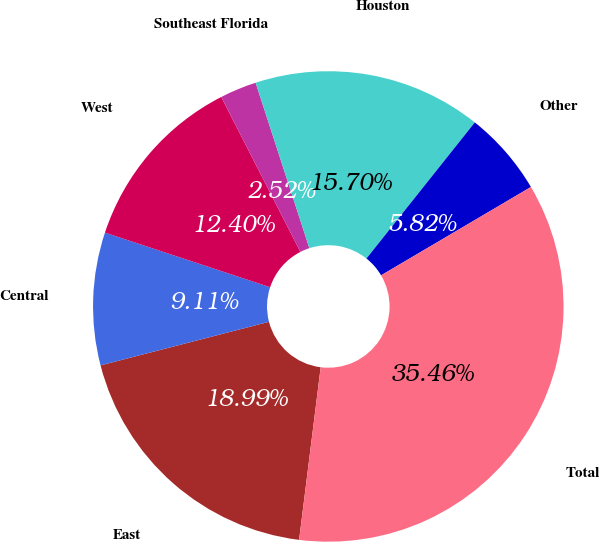Convert chart. <chart><loc_0><loc_0><loc_500><loc_500><pie_chart><fcel>East<fcel>Central<fcel>West<fcel>Southeast Florida<fcel>Houston<fcel>Other<fcel>Total<nl><fcel>18.99%<fcel>9.11%<fcel>12.4%<fcel>2.52%<fcel>15.7%<fcel>5.82%<fcel>35.46%<nl></chart> 